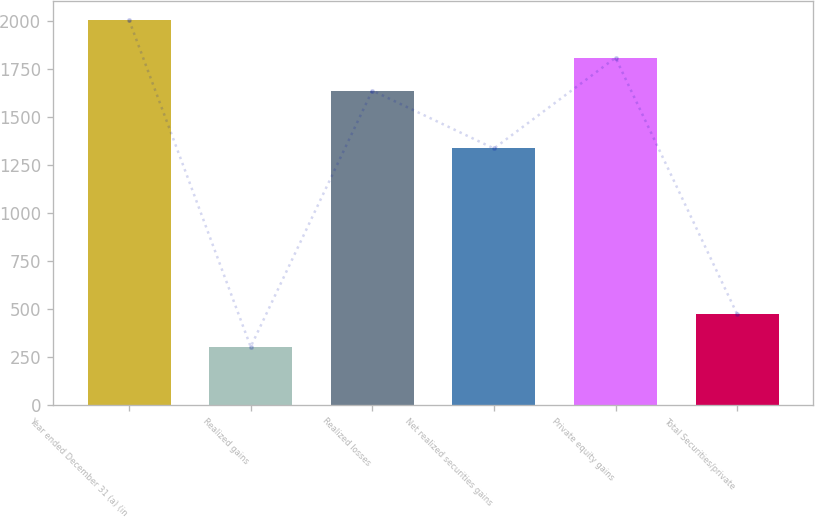Convert chart to OTSL. <chart><loc_0><loc_0><loc_500><loc_500><bar_chart><fcel>Year ended December 31 (a) (in<fcel>Realized gains<fcel>Realized losses<fcel>Net realized securities gains<fcel>Private equity gains<fcel>Total Securities/private<nl><fcel>2005<fcel>302<fcel>1638<fcel>1336<fcel>1809<fcel>473<nl></chart> 